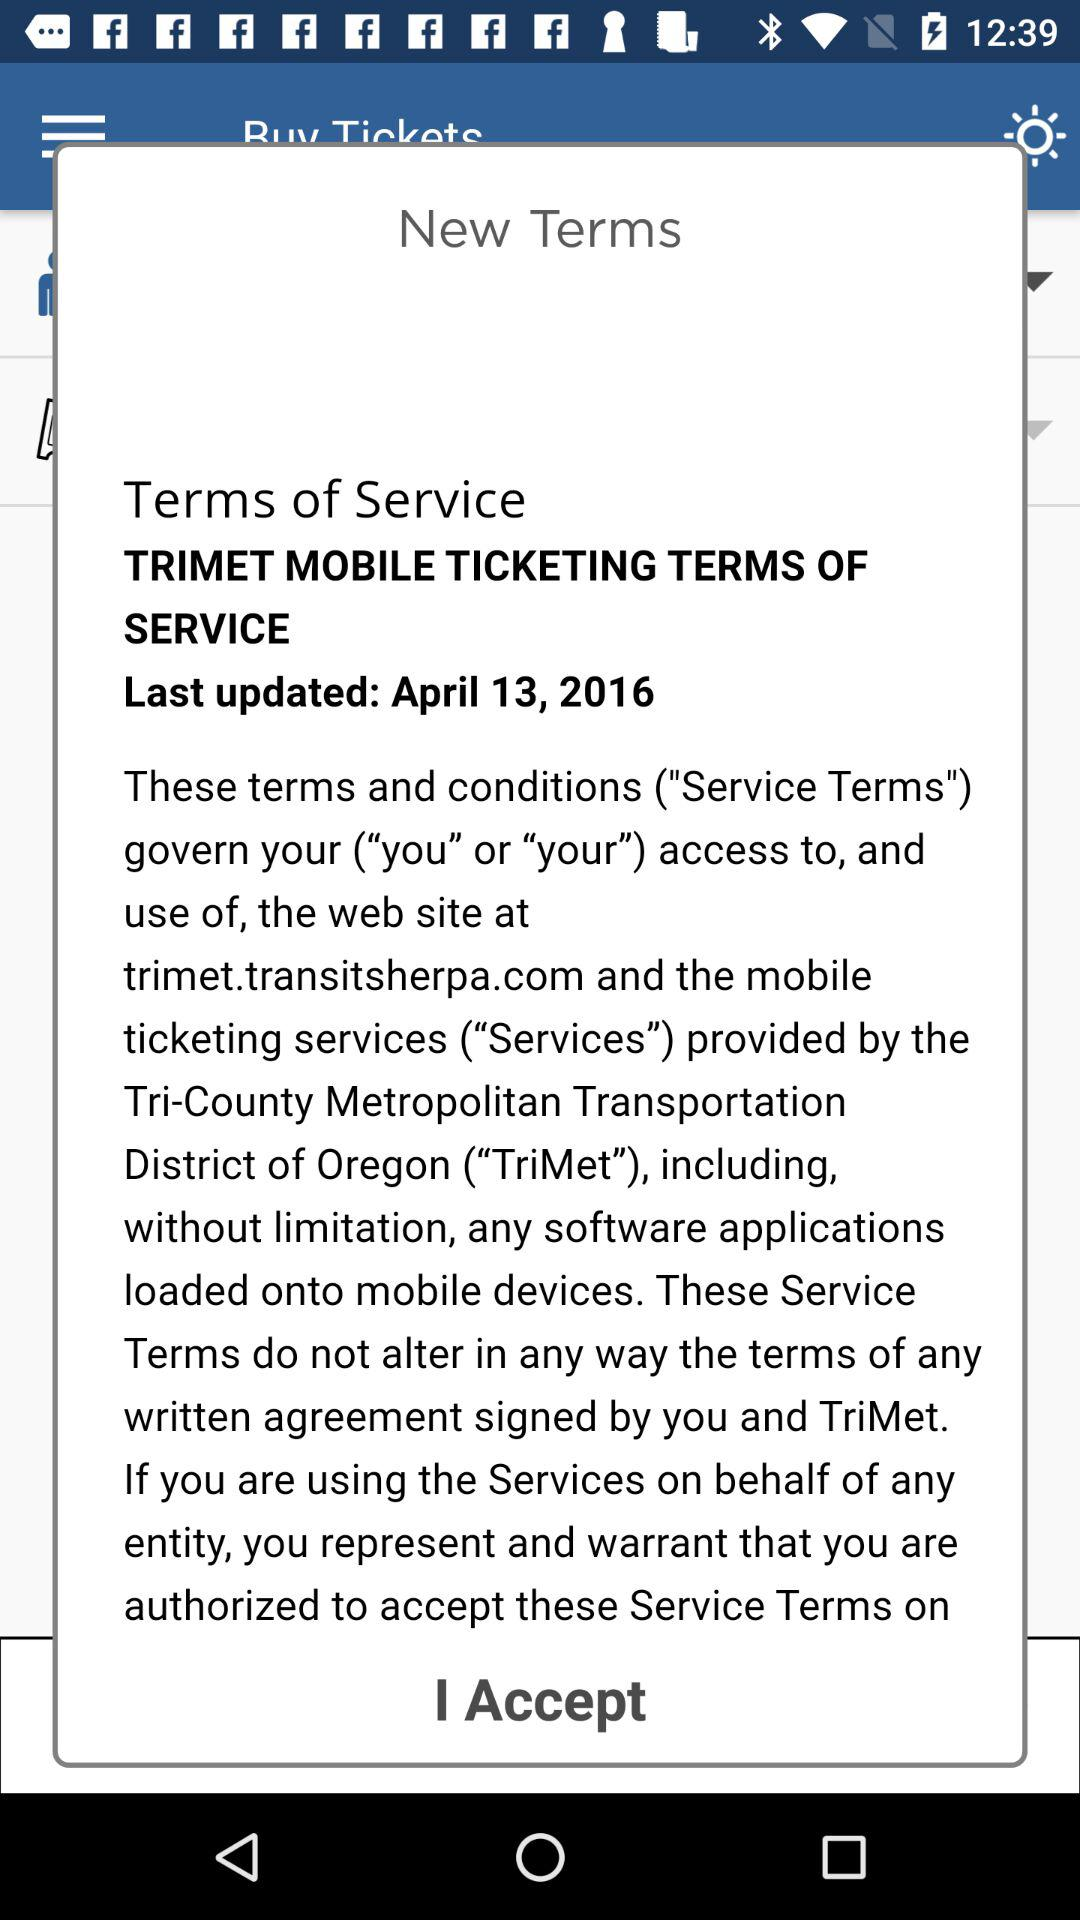What is the last updated date? The last updated date is April 13, 2016. 